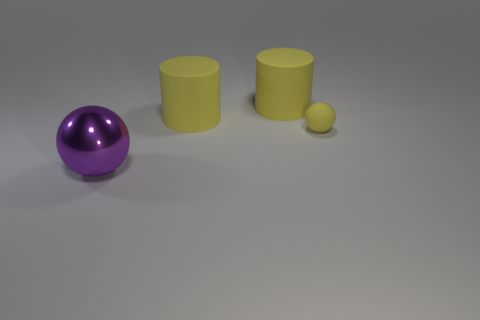Add 4 large red metal objects. How many objects exist? 8 Subtract all yellow spheres. How many spheres are left? 1 Add 3 big cylinders. How many big cylinders exist? 5 Subtract 0 blue cubes. How many objects are left? 4 Subtract all big things. Subtract all yellow balls. How many objects are left? 0 Add 2 matte cylinders. How many matte cylinders are left? 4 